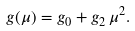<formula> <loc_0><loc_0><loc_500><loc_500>g ( \mu ) = g _ { 0 } + g _ { 2 } \, \mu ^ { 2 } .</formula> 